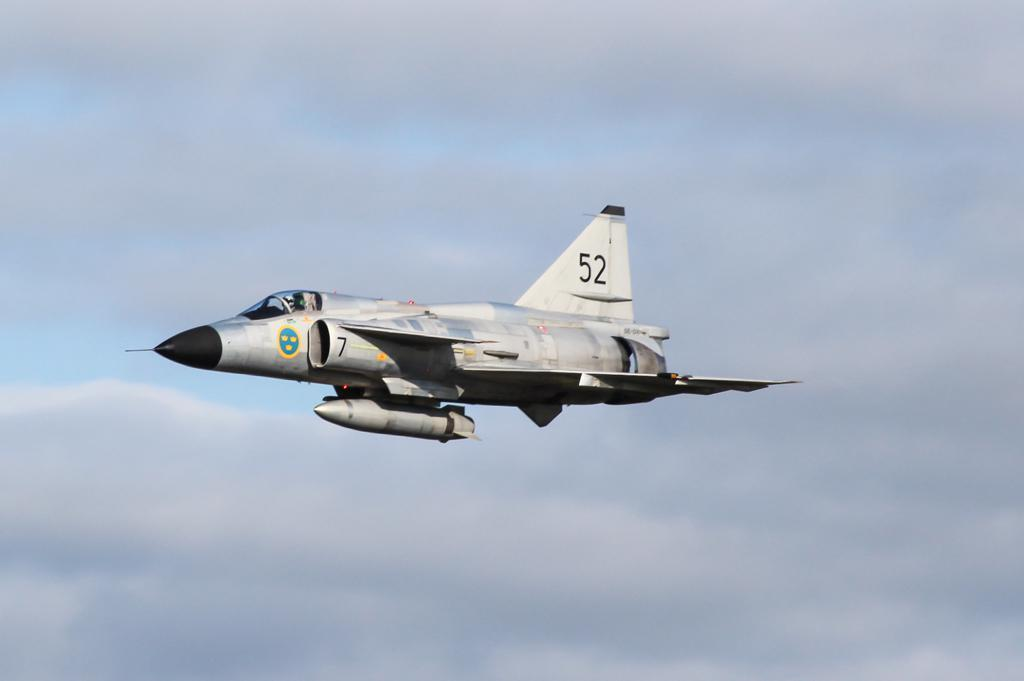<image>
Share a concise interpretation of the image provided. A fighter jet in mid flight with a black nose and the number fifty two on the tail wing. 